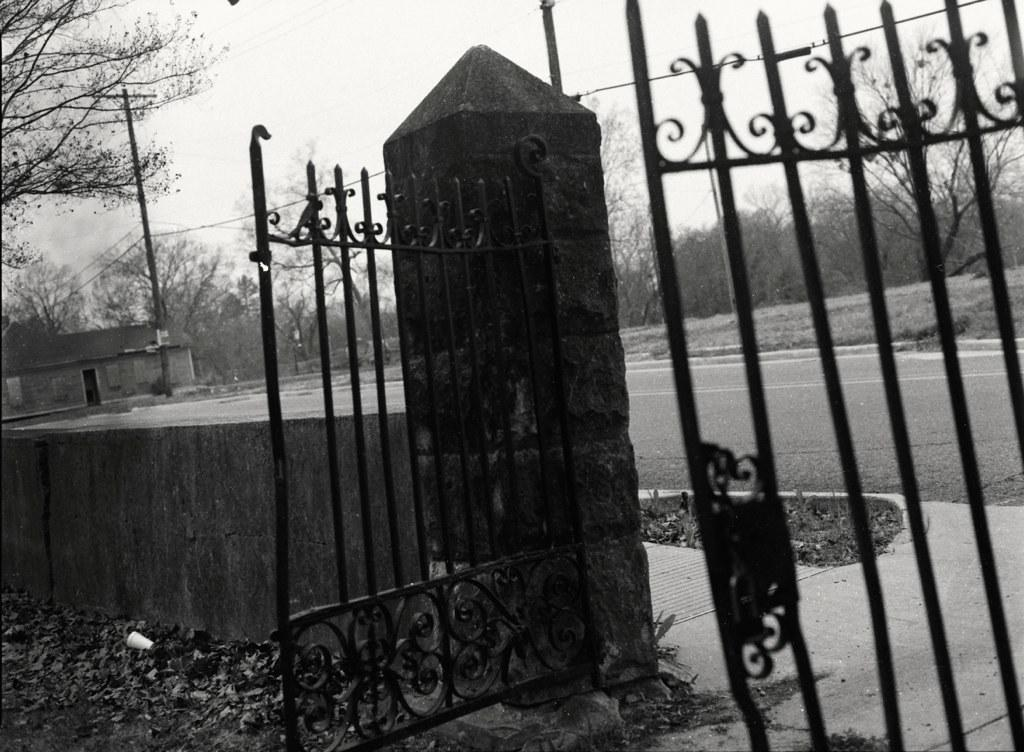What type of structure is in the foreground of the image? There is a grill gate in the image. What other structures can be seen in the image? There is a small boundary wall and a small shed house visible in the image. What is located in the background of the image? There is an electric pole and trees visible in the background. Where is the pail located in the image? There is no pail present in the image. What type of ant can be seen crawling on the grill gate? There are no ants visible in the image, let alone a specific type of ant. 